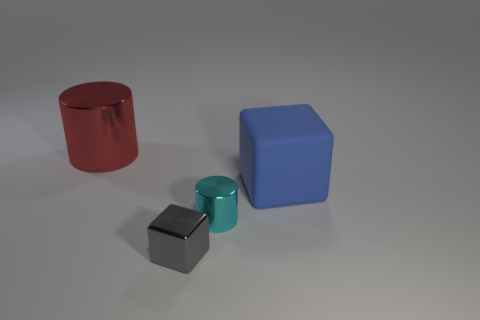Is there anything else that is the same material as the big blue object?
Offer a terse response. No. What is the material of the object that is to the right of the small gray thing and in front of the blue matte block?
Ensure brevity in your answer.  Metal. The big object that is the same shape as the tiny cyan shiny thing is what color?
Keep it short and to the point. Red. The metallic cube has what size?
Your response must be concise. Small. What color is the big thing that is behind the big thing that is in front of the red metal cylinder?
Provide a short and direct response. Red. How many objects are to the right of the large red cylinder and to the left of the large blue block?
Make the answer very short. 2. Are there more small gray metallic objects than gray balls?
Ensure brevity in your answer.  Yes. What is the material of the tiny cube?
Offer a very short reply. Metal. There is a cylinder that is on the left side of the tiny gray shiny block; how many small metal cylinders are in front of it?
Ensure brevity in your answer.  1. There is a metal cube; does it have the same color as the shiny cylinder behind the large matte block?
Make the answer very short. No. 